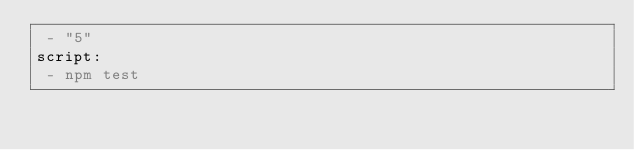<code> <loc_0><loc_0><loc_500><loc_500><_YAML_> - "5"
script:
 - npm test</code> 